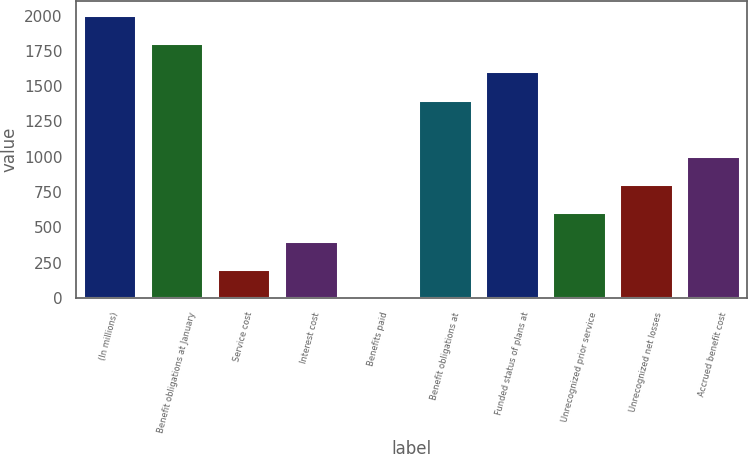<chart> <loc_0><loc_0><loc_500><loc_500><bar_chart><fcel>(In millions)<fcel>Benefit obligations at January<fcel>Service cost<fcel>Interest cost<fcel>Benefits paid<fcel>Benefit obligations at<fcel>Funded status of plans at<fcel>Unrecognized prior service<fcel>Unrecognized net losses<fcel>Accrued benefit cost<nl><fcel>2004<fcel>1804.1<fcel>204.9<fcel>404.8<fcel>5<fcel>1404.3<fcel>1604.2<fcel>604.7<fcel>804.6<fcel>1004.5<nl></chart> 